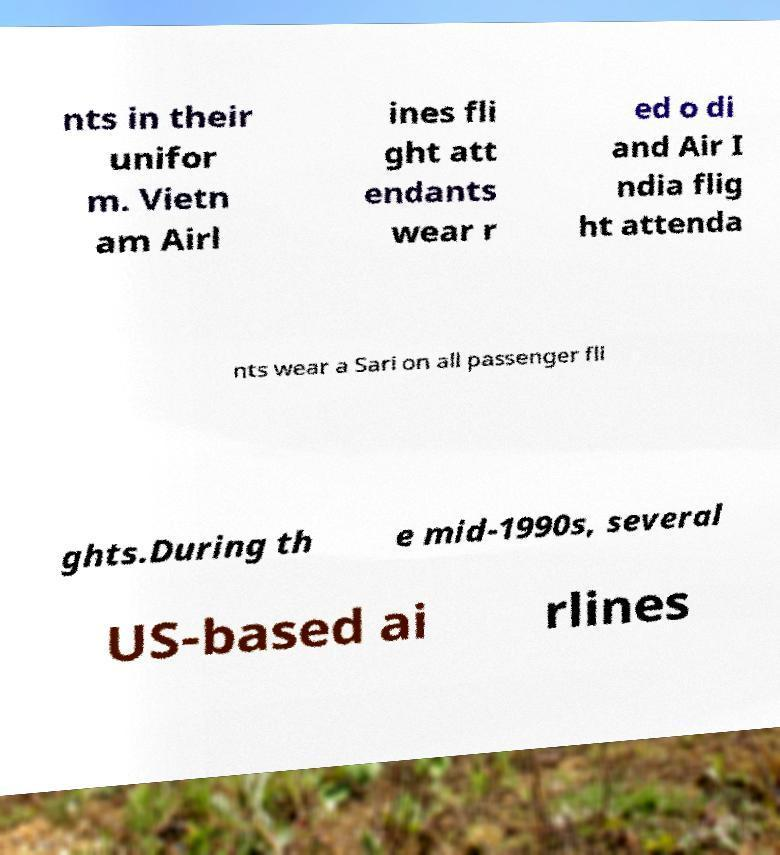Could you extract and type out the text from this image? nts in their unifor m. Vietn am Airl ines fli ght att endants wear r ed o di and Air I ndia flig ht attenda nts wear a Sari on all passenger fli ghts.During th e mid-1990s, several US-based ai rlines 